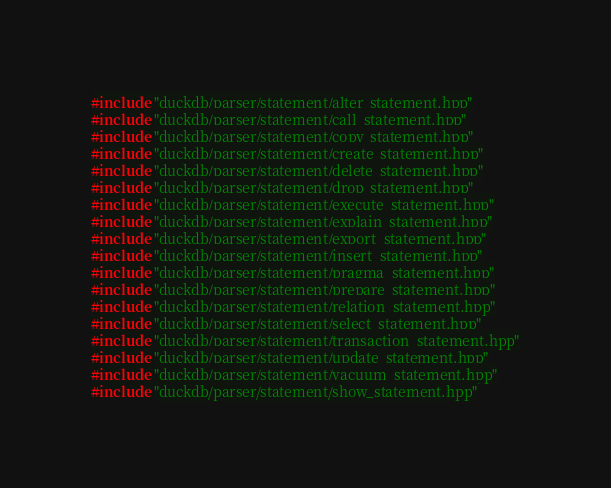Convert code to text. <code><loc_0><loc_0><loc_500><loc_500><_C++_>#include "duckdb/parser/statement/alter_statement.hpp"
#include "duckdb/parser/statement/call_statement.hpp"
#include "duckdb/parser/statement/copy_statement.hpp"
#include "duckdb/parser/statement/create_statement.hpp"
#include "duckdb/parser/statement/delete_statement.hpp"
#include "duckdb/parser/statement/drop_statement.hpp"
#include "duckdb/parser/statement/execute_statement.hpp"
#include "duckdb/parser/statement/explain_statement.hpp"
#include "duckdb/parser/statement/export_statement.hpp"
#include "duckdb/parser/statement/insert_statement.hpp"
#include "duckdb/parser/statement/pragma_statement.hpp"
#include "duckdb/parser/statement/prepare_statement.hpp"
#include "duckdb/parser/statement/relation_statement.hpp"
#include "duckdb/parser/statement/select_statement.hpp"
#include "duckdb/parser/statement/transaction_statement.hpp"
#include "duckdb/parser/statement/update_statement.hpp"
#include "duckdb/parser/statement/vacuum_statement.hpp"
#include "duckdb/parser/statement/show_statement.hpp"
</code> 